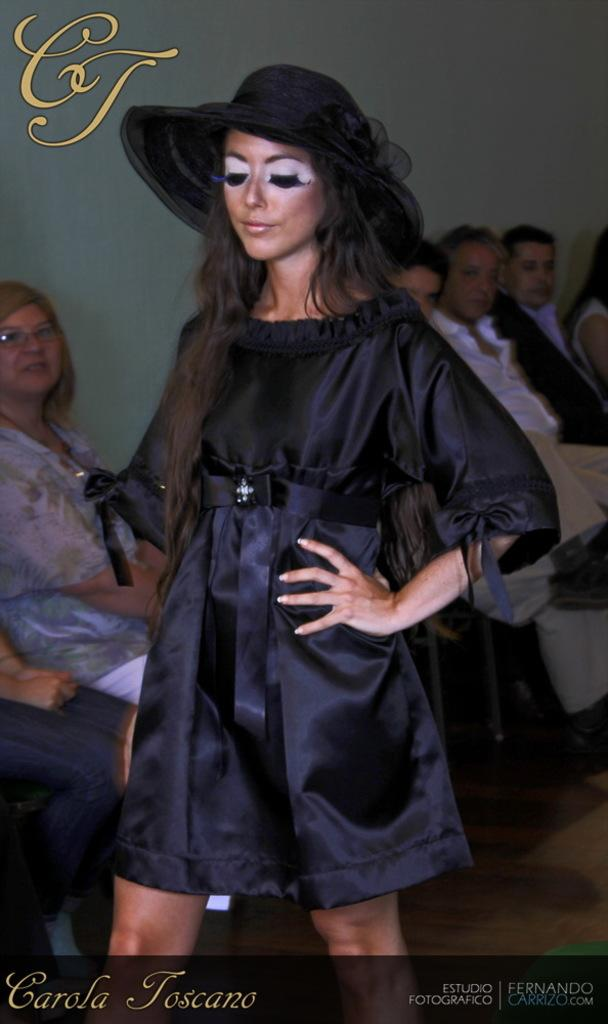Who is the main subject in the foreground of the image? There is a woman in the foreground of the image. What is the woman wearing on her head? The woman is wearing a hat. What color is the woman's dress? The woman is wearing a black dress. What can be seen at the bottom of the image? There is some text at the bottom of the image. What is happening in the background of the image? There are people sitting near a wall in the background of the image. How many legs does the part of the wall have in the image? There is no part of the wall with legs in the image; the wall is a stationary structure. 